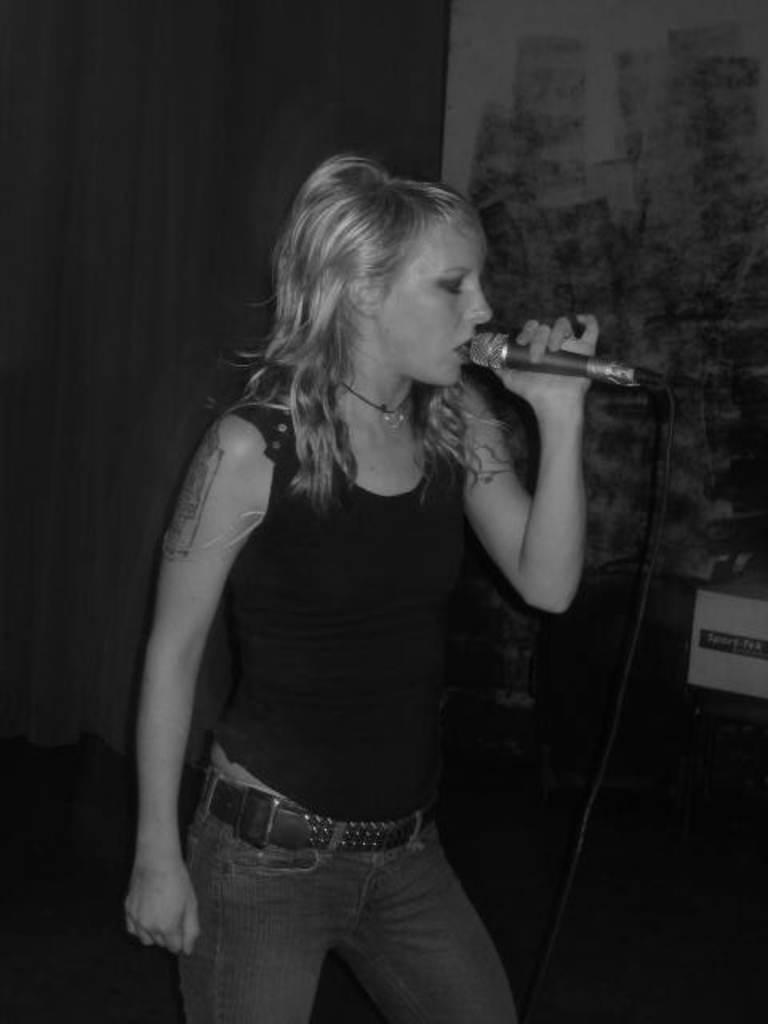Who is the main subject in the image? There is a woman in the image. What is the woman doing in the image? The woman is standing and singing into a microphone. Can you describe the microphone the woman is holding? The microphone is black in color. What type of cup can be seen on the sidewalk in the image? There is no cup or sidewalk present in the image; it features a woman holding a black microphone while singing. 